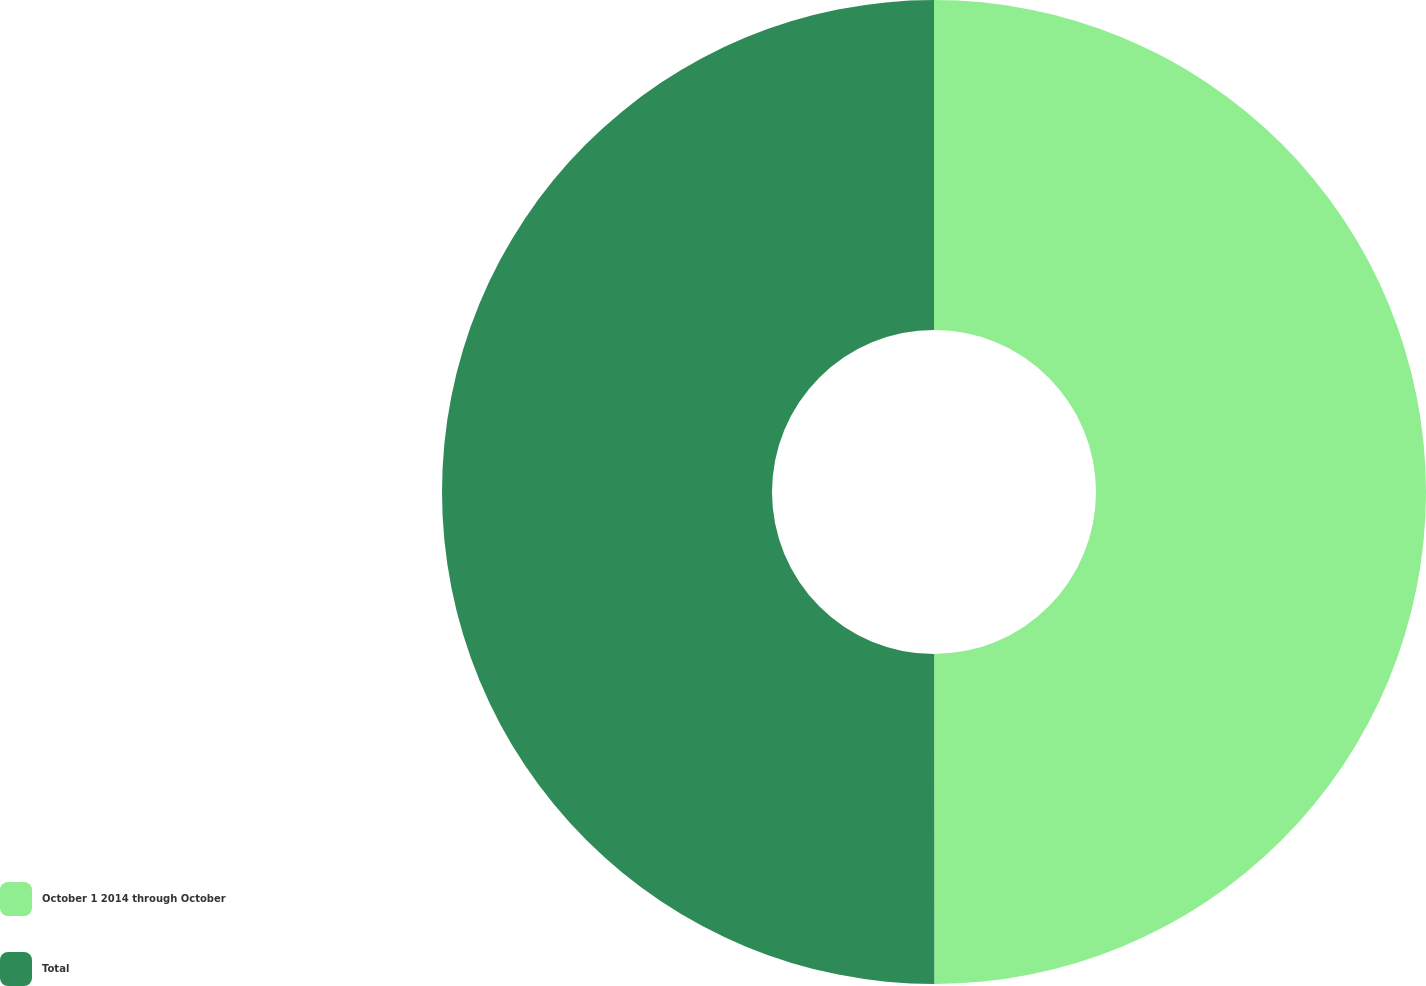Convert chart to OTSL. <chart><loc_0><loc_0><loc_500><loc_500><pie_chart><fcel>October 1 2014 through October<fcel>Total<nl><fcel>49.99%<fcel>50.01%<nl></chart> 